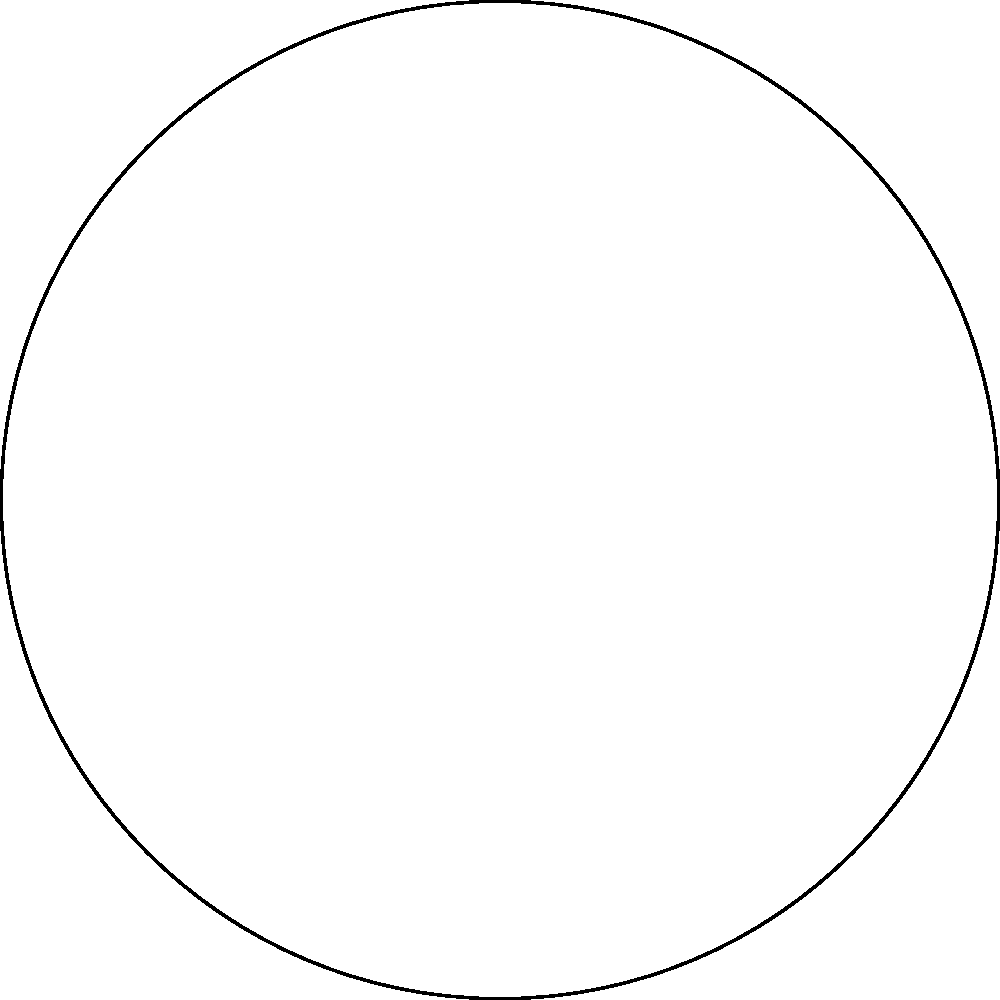In a high-stakes negotiation, you're presented with a challenging geometric problem. Consider a spherical triangle on the surface of a unit sphere, with angles $\alpha$, $\beta$, and $\gamma$, as shown in the red figure. How does the sum of these angles compare to the sum of angles in a Euclidean triangle (shown in black)? If the spherical excess $E = \alpha + \beta + \gamma - \pi$ radians, express the area $A$ of the spherical triangle in terms of $E$. Let's approach this step-by-step:

1) In Euclidean geometry, the sum of angles in a triangle is always $\pi$ radians (or 180°).

2) In spherical geometry, the sum of angles in a triangle is always greater than $\pi$ radians. This excess is called the spherical excess, denoted as $E$.

3) The spherical excess is defined as:
   $E = \alpha + \beta + \gamma - \pi$ radians

4) There's a fundamental theorem in spherical geometry called Girard's Theorem, which relates the area of a spherical triangle to its spherical excess.

5) Girard's Theorem states that the area $A$ of a spherical triangle on a unit sphere is equal to its spherical excess. Mathematically:
   $A = E = \alpha + \beta + \gamma - \pi$ radians

6) Note that this area is dimensionless because it's on a unit sphere. To get the actual area, you'd multiply by $R^2$, where $R$ is the radius of the sphere.

7) This result is strikingly different from Euclidean geometry, where the area of a triangle is independent of its angles.

Thus, the area of the spherical triangle is directly given by its spherical excess $E$.
Answer: $A = E$ radians 